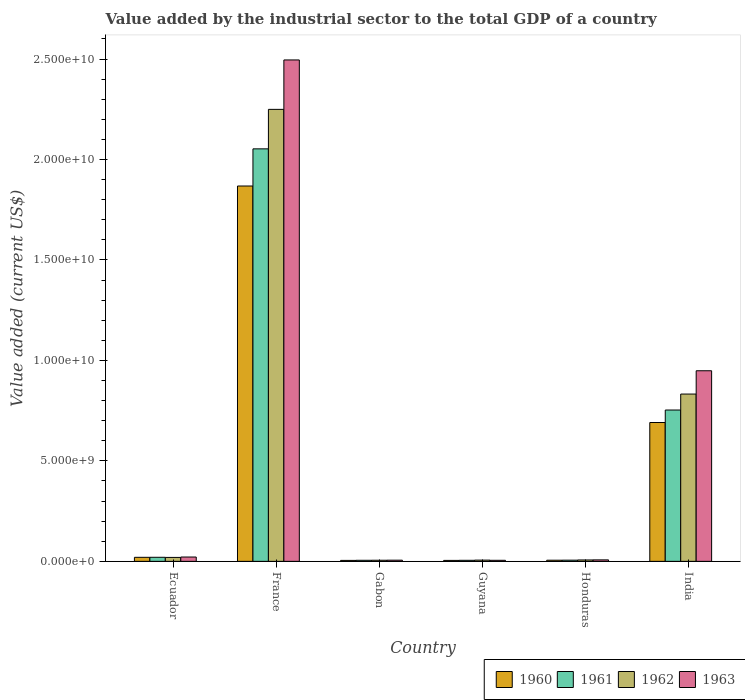Are the number of bars on each tick of the X-axis equal?
Offer a very short reply. Yes. What is the label of the 5th group of bars from the left?
Make the answer very short. Honduras. In how many cases, is the number of bars for a given country not equal to the number of legend labels?
Keep it short and to the point. 0. What is the value added by the industrial sector to the total GDP in 1962 in Gabon?
Offer a very short reply. 5.59e+07. Across all countries, what is the maximum value added by the industrial sector to the total GDP in 1962?
Offer a terse response. 2.25e+1. Across all countries, what is the minimum value added by the industrial sector to the total GDP in 1960?
Make the answer very short. 4.74e+07. In which country was the value added by the industrial sector to the total GDP in 1962 minimum?
Your answer should be very brief. Gabon. What is the total value added by the industrial sector to the total GDP in 1962 in the graph?
Your answer should be very brief. 3.12e+1. What is the difference between the value added by the industrial sector to the total GDP in 1963 in Ecuador and that in India?
Offer a terse response. -9.27e+09. What is the difference between the value added by the industrial sector to the total GDP in 1961 in Guyana and the value added by the industrial sector to the total GDP in 1962 in Ecuador?
Provide a succinct answer. -1.44e+08. What is the average value added by the industrial sector to the total GDP in 1961 per country?
Your response must be concise. 4.74e+09. What is the difference between the value added by the industrial sector to the total GDP of/in 1960 and value added by the industrial sector to the total GDP of/in 1963 in Ecuador?
Offer a very short reply. -1.55e+07. What is the ratio of the value added by the industrial sector to the total GDP in 1962 in France to that in Gabon?
Provide a short and direct response. 402.11. What is the difference between the highest and the second highest value added by the industrial sector to the total GDP in 1962?
Keep it short and to the point. 8.13e+09. What is the difference between the highest and the lowest value added by the industrial sector to the total GDP in 1961?
Provide a short and direct response. 2.05e+1. In how many countries, is the value added by the industrial sector to the total GDP in 1961 greater than the average value added by the industrial sector to the total GDP in 1961 taken over all countries?
Your response must be concise. 2. What does the 2nd bar from the right in Guyana represents?
Ensure brevity in your answer.  1962. Is it the case that in every country, the sum of the value added by the industrial sector to the total GDP in 1960 and value added by the industrial sector to the total GDP in 1962 is greater than the value added by the industrial sector to the total GDP in 1963?
Your response must be concise. Yes. Are all the bars in the graph horizontal?
Your response must be concise. No. What is the difference between two consecutive major ticks on the Y-axis?
Keep it short and to the point. 5.00e+09. Are the values on the major ticks of Y-axis written in scientific E-notation?
Provide a short and direct response. Yes. How many legend labels are there?
Provide a short and direct response. 4. What is the title of the graph?
Keep it short and to the point. Value added by the industrial sector to the total GDP of a country. Does "1992" appear as one of the legend labels in the graph?
Your answer should be compact. No. What is the label or title of the Y-axis?
Give a very brief answer. Value added (current US$). What is the Value added (current US$) of 1960 in Ecuador?
Your response must be concise. 2.01e+08. What is the Value added (current US$) in 1961 in Ecuador?
Your response must be concise. 2.02e+08. What is the Value added (current US$) in 1962 in Ecuador?
Provide a short and direct response. 1.96e+08. What is the Value added (current US$) of 1963 in Ecuador?
Ensure brevity in your answer.  2.16e+08. What is the Value added (current US$) of 1960 in France?
Your response must be concise. 1.87e+1. What is the Value added (current US$) of 1961 in France?
Keep it short and to the point. 2.05e+1. What is the Value added (current US$) of 1962 in France?
Make the answer very short. 2.25e+1. What is the Value added (current US$) of 1963 in France?
Offer a very short reply. 2.50e+1. What is the Value added (current US$) in 1960 in Gabon?
Provide a succinct answer. 4.80e+07. What is the Value added (current US$) in 1961 in Gabon?
Provide a succinct answer. 5.29e+07. What is the Value added (current US$) of 1962 in Gabon?
Offer a terse response. 5.59e+07. What is the Value added (current US$) in 1963 in Gabon?
Make the answer very short. 5.89e+07. What is the Value added (current US$) in 1960 in Guyana?
Provide a short and direct response. 4.74e+07. What is the Value added (current US$) in 1961 in Guyana?
Your answer should be very brief. 5.23e+07. What is the Value added (current US$) of 1962 in Guyana?
Offer a very short reply. 6.20e+07. What is the Value added (current US$) of 1963 in Guyana?
Your answer should be compact. 5.21e+07. What is the Value added (current US$) in 1960 in Honduras?
Your answer should be very brief. 5.73e+07. What is the Value added (current US$) in 1961 in Honduras?
Give a very brief answer. 5.94e+07. What is the Value added (current US$) of 1962 in Honduras?
Make the answer very short. 6.92e+07. What is the Value added (current US$) in 1963 in Honduras?
Ensure brevity in your answer.  7.38e+07. What is the Value added (current US$) of 1960 in India?
Provide a succinct answer. 6.91e+09. What is the Value added (current US$) in 1961 in India?
Make the answer very short. 7.53e+09. What is the Value added (current US$) of 1962 in India?
Keep it short and to the point. 8.33e+09. What is the Value added (current US$) in 1963 in India?
Keep it short and to the point. 9.49e+09. Across all countries, what is the maximum Value added (current US$) of 1960?
Your response must be concise. 1.87e+1. Across all countries, what is the maximum Value added (current US$) of 1961?
Give a very brief answer. 2.05e+1. Across all countries, what is the maximum Value added (current US$) of 1962?
Offer a very short reply. 2.25e+1. Across all countries, what is the maximum Value added (current US$) of 1963?
Make the answer very short. 2.50e+1. Across all countries, what is the minimum Value added (current US$) in 1960?
Your answer should be compact. 4.74e+07. Across all countries, what is the minimum Value added (current US$) of 1961?
Make the answer very short. 5.23e+07. Across all countries, what is the minimum Value added (current US$) in 1962?
Provide a succinct answer. 5.59e+07. Across all countries, what is the minimum Value added (current US$) of 1963?
Provide a short and direct response. 5.21e+07. What is the total Value added (current US$) in 1960 in the graph?
Provide a succinct answer. 2.59e+1. What is the total Value added (current US$) of 1961 in the graph?
Keep it short and to the point. 2.84e+1. What is the total Value added (current US$) of 1962 in the graph?
Your answer should be very brief. 3.12e+1. What is the total Value added (current US$) of 1963 in the graph?
Keep it short and to the point. 3.48e+1. What is the difference between the Value added (current US$) of 1960 in Ecuador and that in France?
Keep it short and to the point. -1.85e+1. What is the difference between the Value added (current US$) of 1961 in Ecuador and that in France?
Provide a short and direct response. -2.03e+1. What is the difference between the Value added (current US$) in 1962 in Ecuador and that in France?
Provide a short and direct response. -2.23e+1. What is the difference between the Value added (current US$) of 1963 in Ecuador and that in France?
Provide a short and direct response. -2.47e+1. What is the difference between the Value added (current US$) of 1960 in Ecuador and that in Gabon?
Provide a short and direct response. 1.53e+08. What is the difference between the Value added (current US$) of 1961 in Ecuador and that in Gabon?
Provide a short and direct response. 1.49e+08. What is the difference between the Value added (current US$) in 1962 in Ecuador and that in Gabon?
Provide a short and direct response. 1.40e+08. What is the difference between the Value added (current US$) in 1963 in Ecuador and that in Gabon?
Your response must be concise. 1.57e+08. What is the difference between the Value added (current US$) of 1960 in Ecuador and that in Guyana?
Keep it short and to the point. 1.53e+08. What is the difference between the Value added (current US$) of 1961 in Ecuador and that in Guyana?
Your answer should be compact. 1.50e+08. What is the difference between the Value added (current US$) of 1962 in Ecuador and that in Guyana?
Give a very brief answer. 1.34e+08. What is the difference between the Value added (current US$) in 1963 in Ecuador and that in Guyana?
Offer a terse response. 1.64e+08. What is the difference between the Value added (current US$) of 1960 in Ecuador and that in Honduras?
Provide a succinct answer. 1.43e+08. What is the difference between the Value added (current US$) in 1961 in Ecuador and that in Honduras?
Make the answer very short. 1.43e+08. What is the difference between the Value added (current US$) in 1962 in Ecuador and that in Honduras?
Your answer should be very brief. 1.27e+08. What is the difference between the Value added (current US$) in 1963 in Ecuador and that in Honduras?
Your answer should be very brief. 1.42e+08. What is the difference between the Value added (current US$) of 1960 in Ecuador and that in India?
Keep it short and to the point. -6.71e+09. What is the difference between the Value added (current US$) of 1961 in Ecuador and that in India?
Your answer should be compact. -7.33e+09. What is the difference between the Value added (current US$) of 1962 in Ecuador and that in India?
Your answer should be very brief. -8.13e+09. What is the difference between the Value added (current US$) in 1963 in Ecuador and that in India?
Make the answer very short. -9.27e+09. What is the difference between the Value added (current US$) of 1960 in France and that in Gabon?
Keep it short and to the point. 1.86e+1. What is the difference between the Value added (current US$) in 1961 in France and that in Gabon?
Keep it short and to the point. 2.05e+1. What is the difference between the Value added (current US$) in 1962 in France and that in Gabon?
Offer a terse response. 2.24e+1. What is the difference between the Value added (current US$) of 1963 in France and that in Gabon?
Your answer should be very brief. 2.49e+1. What is the difference between the Value added (current US$) of 1960 in France and that in Guyana?
Keep it short and to the point. 1.86e+1. What is the difference between the Value added (current US$) in 1961 in France and that in Guyana?
Make the answer very short. 2.05e+1. What is the difference between the Value added (current US$) in 1962 in France and that in Guyana?
Make the answer very short. 2.24e+1. What is the difference between the Value added (current US$) in 1963 in France and that in Guyana?
Your answer should be very brief. 2.49e+1. What is the difference between the Value added (current US$) of 1960 in France and that in Honduras?
Provide a short and direct response. 1.86e+1. What is the difference between the Value added (current US$) in 1961 in France and that in Honduras?
Make the answer very short. 2.05e+1. What is the difference between the Value added (current US$) of 1962 in France and that in Honduras?
Your response must be concise. 2.24e+1. What is the difference between the Value added (current US$) of 1963 in France and that in Honduras?
Provide a short and direct response. 2.49e+1. What is the difference between the Value added (current US$) in 1960 in France and that in India?
Keep it short and to the point. 1.18e+1. What is the difference between the Value added (current US$) in 1961 in France and that in India?
Your answer should be very brief. 1.30e+1. What is the difference between the Value added (current US$) in 1962 in France and that in India?
Your answer should be very brief. 1.42e+1. What is the difference between the Value added (current US$) in 1963 in France and that in India?
Offer a very short reply. 1.55e+1. What is the difference between the Value added (current US$) of 1960 in Gabon and that in Guyana?
Your response must be concise. 5.58e+05. What is the difference between the Value added (current US$) in 1961 in Gabon and that in Guyana?
Ensure brevity in your answer.  6.49e+05. What is the difference between the Value added (current US$) of 1962 in Gabon and that in Guyana?
Provide a succinct answer. -6.07e+06. What is the difference between the Value added (current US$) in 1963 in Gabon and that in Guyana?
Provide a succinct answer. 6.82e+06. What is the difference between the Value added (current US$) in 1960 in Gabon and that in Honduras?
Make the answer very short. -9.32e+06. What is the difference between the Value added (current US$) in 1961 in Gabon and that in Honduras?
Ensure brevity in your answer.  -6.43e+06. What is the difference between the Value added (current US$) in 1962 in Gabon and that in Honduras?
Make the answer very short. -1.33e+07. What is the difference between the Value added (current US$) of 1963 in Gabon and that in Honduras?
Give a very brief answer. -1.49e+07. What is the difference between the Value added (current US$) in 1960 in Gabon and that in India?
Provide a short and direct response. -6.86e+09. What is the difference between the Value added (current US$) in 1961 in Gabon and that in India?
Ensure brevity in your answer.  -7.48e+09. What is the difference between the Value added (current US$) in 1962 in Gabon and that in India?
Provide a succinct answer. -8.27e+09. What is the difference between the Value added (current US$) of 1963 in Gabon and that in India?
Offer a terse response. -9.43e+09. What is the difference between the Value added (current US$) of 1960 in Guyana and that in Honduras?
Provide a short and direct response. -9.88e+06. What is the difference between the Value added (current US$) in 1961 in Guyana and that in Honduras?
Provide a succinct answer. -7.08e+06. What is the difference between the Value added (current US$) in 1962 in Guyana and that in Honduras?
Keep it short and to the point. -7.19e+06. What is the difference between the Value added (current US$) in 1963 in Guyana and that in Honduras?
Offer a terse response. -2.17e+07. What is the difference between the Value added (current US$) in 1960 in Guyana and that in India?
Provide a succinct answer. -6.86e+09. What is the difference between the Value added (current US$) of 1961 in Guyana and that in India?
Make the answer very short. -7.48e+09. What is the difference between the Value added (current US$) of 1962 in Guyana and that in India?
Offer a terse response. -8.26e+09. What is the difference between the Value added (current US$) of 1963 in Guyana and that in India?
Your answer should be compact. -9.43e+09. What is the difference between the Value added (current US$) of 1960 in Honduras and that in India?
Your response must be concise. -6.85e+09. What is the difference between the Value added (current US$) of 1961 in Honduras and that in India?
Your response must be concise. -7.47e+09. What is the difference between the Value added (current US$) of 1962 in Honduras and that in India?
Your answer should be compact. -8.26e+09. What is the difference between the Value added (current US$) of 1963 in Honduras and that in India?
Ensure brevity in your answer.  -9.41e+09. What is the difference between the Value added (current US$) in 1960 in Ecuador and the Value added (current US$) in 1961 in France?
Offer a very short reply. -2.03e+1. What is the difference between the Value added (current US$) of 1960 in Ecuador and the Value added (current US$) of 1962 in France?
Your answer should be very brief. -2.23e+1. What is the difference between the Value added (current US$) in 1960 in Ecuador and the Value added (current US$) in 1963 in France?
Give a very brief answer. -2.48e+1. What is the difference between the Value added (current US$) of 1961 in Ecuador and the Value added (current US$) of 1962 in France?
Your response must be concise. -2.23e+1. What is the difference between the Value added (current US$) in 1961 in Ecuador and the Value added (current US$) in 1963 in France?
Provide a succinct answer. -2.48e+1. What is the difference between the Value added (current US$) of 1962 in Ecuador and the Value added (current US$) of 1963 in France?
Make the answer very short. -2.48e+1. What is the difference between the Value added (current US$) in 1960 in Ecuador and the Value added (current US$) in 1961 in Gabon?
Offer a terse response. 1.48e+08. What is the difference between the Value added (current US$) in 1960 in Ecuador and the Value added (current US$) in 1962 in Gabon?
Offer a very short reply. 1.45e+08. What is the difference between the Value added (current US$) of 1960 in Ecuador and the Value added (current US$) of 1963 in Gabon?
Give a very brief answer. 1.42e+08. What is the difference between the Value added (current US$) of 1961 in Ecuador and the Value added (current US$) of 1962 in Gabon?
Provide a short and direct response. 1.46e+08. What is the difference between the Value added (current US$) of 1961 in Ecuador and the Value added (current US$) of 1963 in Gabon?
Make the answer very short. 1.43e+08. What is the difference between the Value added (current US$) in 1962 in Ecuador and the Value added (current US$) in 1963 in Gabon?
Your response must be concise. 1.37e+08. What is the difference between the Value added (current US$) of 1960 in Ecuador and the Value added (current US$) of 1961 in Guyana?
Your answer should be very brief. 1.48e+08. What is the difference between the Value added (current US$) of 1960 in Ecuador and the Value added (current US$) of 1962 in Guyana?
Your answer should be very brief. 1.39e+08. What is the difference between the Value added (current US$) of 1960 in Ecuador and the Value added (current US$) of 1963 in Guyana?
Offer a very short reply. 1.49e+08. What is the difference between the Value added (current US$) of 1961 in Ecuador and the Value added (current US$) of 1962 in Guyana?
Keep it short and to the point. 1.40e+08. What is the difference between the Value added (current US$) in 1961 in Ecuador and the Value added (current US$) in 1963 in Guyana?
Provide a short and direct response. 1.50e+08. What is the difference between the Value added (current US$) in 1962 in Ecuador and the Value added (current US$) in 1963 in Guyana?
Give a very brief answer. 1.44e+08. What is the difference between the Value added (current US$) in 1960 in Ecuador and the Value added (current US$) in 1961 in Honduras?
Give a very brief answer. 1.41e+08. What is the difference between the Value added (current US$) in 1960 in Ecuador and the Value added (current US$) in 1962 in Honduras?
Give a very brief answer. 1.31e+08. What is the difference between the Value added (current US$) of 1960 in Ecuador and the Value added (current US$) of 1963 in Honduras?
Your response must be concise. 1.27e+08. What is the difference between the Value added (current US$) of 1961 in Ecuador and the Value added (current US$) of 1962 in Honduras?
Offer a very short reply. 1.33e+08. What is the difference between the Value added (current US$) of 1961 in Ecuador and the Value added (current US$) of 1963 in Honduras?
Make the answer very short. 1.28e+08. What is the difference between the Value added (current US$) in 1962 in Ecuador and the Value added (current US$) in 1963 in Honduras?
Offer a very short reply. 1.22e+08. What is the difference between the Value added (current US$) in 1960 in Ecuador and the Value added (current US$) in 1961 in India?
Your response must be concise. -7.33e+09. What is the difference between the Value added (current US$) in 1960 in Ecuador and the Value added (current US$) in 1962 in India?
Offer a terse response. -8.13e+09. What is the difference between the Value added (current US$) in 1960 in Ecuador and the Value added (current US$) in 1963 in India?
Provide a short and direct response. -9.28e+09. What is the difference between the Value added (current US$) in 1961 in Ecuador and the Value added (current US$) in 1962 in India?
Give a very brief answer. -8.12e+09. What is the difference between the Value added (current US$) of 1961 in Ecuador and the Value added (current US$) of 1963 in India?
Your response must be concise. -9.28e+09. What is the difference between the Value added (current US$) in 1962 in Ecuador and the Value added (current US$) in 1963 in India?
Give a very brief answer. -9.29e+09. What is the difference between the Value added (current US$) in 1960 in France and the Value added (current US$) in 1961 in Gabon?
Make the answer very short. 1.86e+1. What is the difference between the Value added (current US$) of 1960 in France and the Value added (current US$) of 1962 in Gabon?
Offer a terse response. 1.86e+1. What is the difference between the Value added (current US$) in 1960 in France and the Value added (current US$) in 1963 in Gabon?
Ensure brevity in your answer.  1.86e+1. What is the difference between the Value added (current US$) of 1961 in France and the Value added (current US$) of 1962 in Gabon?
Provide a succinct answer. 2.05e+1. What is the difference between the Value added (current US$) of 1961 in France and the Value added (current US$) of 1963 in Gabon?
Your answer should be very brief. 2.05e+1. What is the difference between the Value added (current US$) of 1962 in France and the Value added (current US$) of 1963 in Gabon?
Provide a short and direct response. 2.24e+1. What is the difference between the Value added (current US$) of 1960 in France and the Value added (current US$) of 1961 in Guyana?
Keep it short and to the point. 1.86e+1. What is the difference between the Value added (current US$) in 1960 in France and the Value added (current US$) in 1962 in Guyana?
Keep it short and to the point. 1.86e+1. What is the difference between the Value added (current US$) of 1960 in France and the Value added (current US$) of 1963 in Guyana?
Your response must be concise. 1.86e+1. What is the difference between the Value added (current US$) of 1961 in France and the Value added (current US$) of 1962 in Guyana?
Offer a terse response. 2.05e+1. What is the difference between the Value added (current US$) of 1961 in France and the Value added (current US$) of 1963 in Guyana?
Make the answer very short. 2.05e+1. What is the difference between the Value added (current US$) of 1962 in France and the Value added (current US$) of 1963 in Guyana?
Provide a short and direct response. 2.24e+1. What is the difference between the Value added (current US$) in 1960 in France and the Value added (current US$) in 1961 in Honduras?
Provide a short and direct response. 1.86e+1. What is the difference between the Value added (current US$) in 1960 in France and the Value added (current US$) in 1962 in Honduras?
Provide a succinct answer. 1.86e+1. What is the difference between the Value added (current US$) in 1960 in France and the Value added (current US$) in 1963 in Honduras?
Offer a terse response. 1.86e+1. What is the difference between the Value added (current US$) in 1961 in France and the Value added (current US$) in 1962 in Honduras?
Provide a succinct answer. 2.05e+1. What is the difference between the Value added (current US$) of 1961 in France and the Value added (current US$) of 1963 in Honduras?
Keep it short and to the point. 2.05e+1. What is the difference between the Value added (current US$) in 1962 in France and the Value added (current US$) in 1963 in Honduras?
Ensure brevity in your answer.  2.24e+1. What is the difference between the Value added (current US$) in 1960 in France and the Value added (current US$) in 1961 in India?
Offer a very short reply. 1.11e+1. What is the difference between the Value added (current US$) of 1960 in France and the Value added (current US$) of 1962 in India?
Give a very brief answer. 1.04e+1. What is the difference between the Value added (current US$) of 1960 in France and the Value added (current US$) of 1963 in India?
Offer a terse response. 9.19e+09. What is the difference between the Value added (current US$) of 1961 in France and the Value added (current US$) of 1962 in India?
Provide a succinct answer. 1.22e+1. What is the difference between the Value added (current US$) of 1961 in France and the Value added (current US$) of 1963 in India?
Offer a very short reply. 1.10e+1. What is the difference between the Value added (current US$) of 1962 in France and the Value added (current US$) of 1963 in India?
Your answer should be compact. 1.30e+1. What is the difference between the Value added (current US$) of 1960 in Gabon and the Value added (current US$) of 1961 in Guyana?
Make the answer very short. -4.28e+06. What is the difference between the Value added (current US$) of 1960 in Gabon and the Value added (current US$) of 1962 in Guyana?
Provide a short and direct response. -1.40e+07. What is the difference between the Value added (current US$) in 1960 in Gabon and the Value added (current US$) in 1963 in Guyana?
Offer a terse response. -4.11e+06. What is the difference between the Value added (current US$) of 1961 in Gabon and the Value added (current US$) of 1962 in Guyana?
Make the answer very short. -9.09e+06. What is the difference between the Value added (current US$) of 1961 in Gabon and the Value added (current US$) of 1963 in Guyana?
Provide a short and direct response. 8.24e+05. What is the difference between the Value added (current US$) of 1962 in Gabon and the Value added (current US$) of 1963 in Guyana?
Provide a short and direct response. 3.85e+06. What is the difference between the Value added (current US$) of 1960 in Gabon and the Value added (current US$) of 1961 in Honduras?
Give a very brief answer. -1.14e+07. What is the difference between the Value added (current US$) of 1960 in Gabon and the Value added (current US$) of 1962 in Honduras?
Provide a succinct answer. -2.12e+07. What is the difference between the Value added (current US$) of 1960 in Gabon and the Value added (current US$) of 1963 in Honduras?
Your answer should be very brief. -2.58e+07. What is the difference between the Value added (current US$) of 1961 in Gabon and the Value added (current US$) of 1962 in Honduras?
Offer a very short reply. -1.63e+07. What is the difference between the Value added (current US$) of 1961 in Gabon and the Value added (current US$) of 1963 in Honduras?
Provide a succinct answer. -2.09e+07. What is the difference between the Value added (current US$) of 1962 in Gabon and the Value added (current US$) of 1963 in Honduras?
Give a very brief answer. -1.79e+07. What is the difference between the Value added (current US$) of 1960 in Gabon and the Value added (current US$) of 1961 in India?
Offer a very short reply. -7.48e+09. What is the difference between the Value added (current US$) of 1960 in Gabon and the Value added (current US$) of 1962 in India?
Provide a succinct answer. -8.28e+09. What is the difference between the Value added (current US$) of 1960 in Gabon and the Value added (current US$) of 1963 in India?
Provide a succinct answer. -9.44e+09. What is the difference between the Value added (current US$) of 1961 in Gabon and the Value added (current US$) of 1962 in India?
Provide a succinct answer. -8.27e+09. What is the difference between the Value added (current US$) in 1961 in Gabon and the Value added (current US$) in 1963 in India?
Your answer should be very brief. -9.43e+09. What is the difference between the Value added (current US$) of 1962 in Gabon and the Value added (current US$) of 1963 in India?
Make the answer very short. -9.43e+09. What is the difference between the Value added (current US$) in 1960 in Guyana and the Value added (current US$) in 1961 in Honduras?
Keep it short and to the point. -1.19e+07. What is the difference between the Value added (current US$) of 1960 in Guyana and the Value added (current US$) of 1962 in Honduras?
Give a very brief answer. -2.18e+07. What is the difference between the Value added (current US$) of 1960 in Guyana and the Value added (current US$) of 1963 in Honduras?
Your response must be concise. -2.64e+07. What is the difference between the Value added (current US$) of 1961 in Guyana and the Value added (current US$) of 1962 in Honduras?
Your answer should be compact. -1.69e+07. What is the difference between the Value added (current US$) of 1961 in Guyana and the Value added (current US$) of 1963 in Honduras?
Give a very brief answer. -2.15e+07. What is the difference between the Value added (current US$) in 1962 in Guyana and the Value added (current US$) in 1963 in Honduras?
Make the answer very short. -1.18e+07. What is the difference between the Value added (current US$) of 1960 in Guyana and the Value added (current US$) of 1961 in India?
Keep it short and to the point. -7.48e+09. What is the difference between the Value added (current US$) of 1960 in Guyana and the Value added (current US$) of 1962 in India?
Offer a very short reply. -8.28e+09. What is the difference between the Value added (current US$) in 1960 in Guyana and the Value added (current US$) in 1963 in India?
Ensure brevity in your answer.  -9.44e+09. What is the difference between the Value added (current US$) in 1961 in Guyana and the Value added (current US$) in 1962 in India?
Give a very brief answer. -8.27e+09. What is the difference between the Value added (current US$) of 1961 in Guyana and the Value added (current US$) of 1963 in India?
Your answer should be very brief. -9.43e+09. What is the difference between the Value added (current US$) of 1962 in Guyana and the Value added (current US$) of 1963 in India?
Provide a succinct answer. -9.42e+09. What is the difference between the Value added (current US$) of 1960 in Honduras and the Value added (current US$) of 1961 in India?
Make the answer very short. -7.47e+09. What is the difference between the Value added (current US$) in 1960 in Honduras and the Value added (current US$) in 1962 in India?
Offer a terse response. -8.27e+09. What is the difference between the Value added (current US$) of 1960 in Honduras and the Value added (current US$) of 1963 in India?
Give a very brief answer. -9.43e+09. What is the difference between the Value added (current US$) in 1961 in Honduras and the Value added (current US$) in 1962 in India?
Offer a very short reply. -8.27e+09. What is the difference between the Value added (current US$) of 1961 in Honduras and the Value added (current US$) of 1963 in India?
Keep it short and to the point. -9.43e+09. What is the difference between the Value added (current US$) in 1962 in Honduras and the Value added (current US$) in 1963 in India?
Provide a short and direct response. -9.42e+09. What is the average Value added (current US$) of 1960 per country?
Offer a terse response. 4.32e+09. What is the average Value added (current US$) in 1961 per country?
Your response must be concise. 4.74e+09. What is the average Value added (current US$) in 1962 per country?
Keep it short and to the point. 5.20e+09. What is the average Value added (current US$) of 1963 per country?
Make the answer very short. 5.81e+09. What is the difference between the Value added (current US$) in 1960 and Value added (current US$) in 1961 in Ecuador?
Your answer should be very brief. -1.51e+06. What is the difference between the Value added (current US$) of 1960 and Value added (current US$) of 1962 in Ecuador?
Offer a terse response. 4.47e+06. What is the difference between the Value added (current US$) of 1960 and Value added (current US$) of 1963 in Ecuador?
Give a very brief answer. -1.55e+07. What is the difference between the Value added (current US$) of 1961 and Value added (current US$) of 1962 in Ecuador?
Your response must be concise. 5.98e+06. What is the difference between the Value added (current US$) of 1961 and Value added (current US$) of 1963 in Ecuador?
Give a very brief answer. -1.39e+07. What is the difference between the Value added (current US$) in 1962 and Value added (current US$) in 1963 in Ecuador?
Offer a very short reply. -1.99e+07. What is the difference between the Value added (current US$) of 1960 and Value added (current US$) of 1961 in France?
Your answer should be very brief. -1.85e+09. What is the difference between the Value added (current US$) in 1960 and Value added (current US$) in 1962 in France?
Provide a short and direct response. -3.81e+09. What is the difference between the Value added (current US$) in 1960 and Value added (current US$) in 1963 in France?
Offer a very short reply. -6.27e+09. What is the difference between the Value added (current US$) in 1961 and Value added (current US$) in 1962 in France?
Offer a very short reply. -1.97e+09. What is the difference between the Value added (current US$) in 1961 and Value added (current US$) in 1963 in France?
Your response must be concise. -4.42e+09. What is the difference between the Value added (current US$) in 1962 and Value added (current US$) in 1963 in France?
Keep it short and to the point. -2.46e+09. What is the difference between the Value added (current US$) in 1960 and Value added (current US$) in 1961 in Gabon?
Make the answer very short. -4.93e+06. What is the difference between the Value added (current US$) of 1960 and Value added (current US$) of 1962 in Gabon?
Keep it short and to the point. -7.96e+06. What is the difference between the Value added (current US$) of 1960 and Value added (current US$) of 1963 in Gabon?
Provide a short and direct response. -1.09e+07. What is the difference between the Value added (current US$) of 1961 and Value added (current US$) of 1962 in Gabon?
Make the answer very short. -3.02e+06. What is the difference between the Value added (current US$) in 1961 and Value added (current US$) in 1963 in Gabon?
Provide a succinct answer. -5.99e+06. What is the difference between the Value added (current US$) of 1962 and Value added (current US$) of 1963 in Gabon?
Give a very brief answer. -2.97e+06. What is the difference between the Value added (current US$) of 1960 and Value added (current US$) of 1961 in Guyana?
Ensure brevity in your answer.  -4.84e+06. What is the difference between the Value added (current US$) in 1960 and Value added (current US$) in 1962 in Guyana?
Your response must be concise. -1.46e+07. What is the difference between the Value added (current US$) of 1960 and Value added (current US$) of 1963 in Guyana?
Offer a terse response. -4.67e+06. What is the difference between the Value added (current US$) in 1961 and Value added (current US$) in 1962 in Guyana?
Offer a very short reply. -9.74e+06. What is the difference between the Value added (current US$) of 1961 and Value added (current US$) of 1963 in Guyana?
Keep it short and to the point. 1.75e+05. What is the difference between the Value added (current US$) of 1962 and Value added (current US$) of 1963 in Guyana?
Provide a succinct answer. 9.92e+06. What is the difference between the Value added (current US$) of 1960 and Value added (current US$) of 1961 in Honduras?
Make the answer very short. -2.05e+06. What is the difference between the Value added (current US$) in 1960 and Value added (current US$) in 1962 in Honduras?
Your response must be concise. -1.19e+07. What is the difference between the Value added (current US$) in 1960 and Value added (current US$) in 1963 in Honduras?
Keep it short and to the point. -1.65e+07. What is the difference between the Value added (current US$) in 1961 and Value added (current US$) in 1962 in Honduras?
Your answer should be very brief. -9.85e+06. What is the difference between the Value added (current US$) in 1961 and Value added (current US$) in 1963 in Honduras?
Your response must be concise. -1.44e+07. What is the difference between the Value added (current US$) in 1962 and Value added (current US$) in 1963 in Honduras?
Provide a short and direct response. -4.60e+06. What is the difference between the Value added (current US$) in 1960 and Value added (current US$) in 1961 in India?
Provide a short and direct response. -6.21e+08. What is the difference between the Value added (current US$) in 1960 and Value added (current US$) in 1962 in India?
Give a very brief answer. -1.42e+09. What is the difference between the Value added (current US$) of 1960 and Value added (current US$) of 1963 in India?
Offer a very short reply. -2.58e+09. What is the difference between the Value added (current US$) in 1961 and Value added (current US$) in 1962 in India?
Offer a terse response. -7.94e+08. What is the difference between the Value added (current US$) of 1961 and Value added (current US$) of 1963 in India?
Your response must be concise. -1.95e+09. What is the difference between the Value added (current US$) in 1962 and Value added (current US$) in 1963 in India?
Ensure brevity in your answer.  -1.16e+09. What is the ratio of the Value added (current US$) in 1960 in Ecuador to that in France?
Your answer should be compact. 0.01. What is the ratio of the Value added (current US$) in 1961 in Ecuador to that in France?
Keep it short and to the point. 0.01. What is the ratio of the Value added (current US$) of 1962 in Ecuador to that in France?
Ensure brevity in your answer.  0.01. What is the ratio of the Value added (current US$) in 1963 in Ecuador to that in France?
Give a very brief answer. 0.01. What is the ratio of the Value added (current US$) of 1960 in Ecuador to that in Gabon?
Ensure brevity in your answer.  4.18. What is the ratio of the Value added (current US$) of 1961 in Ecuador to that in Gabon?
Ensure brevity in your answer.  3.82. What is the ratio of the Value added (current US$) in 1962 in Ecuador to that in Gabon?
Keep it short and to the point. 3.51. What is the ratio of the Value added (current US$) in 1963 in Ecuador to that in Gabon?
Offer a terse response. 3.67. What is the ratio of the Value added (current US$) in 1960 in Ecuador to that in Guyana?
Keep it short and to the point. 4.23. What is the ratio of the Value added (current US$) of 1961 in Ecuador to that in Guyana?
Your answer should be very brief. 3.87. What is the ratio of the Value added (current US$) of 1962 in Ecuador to that in Guyana?
Make the answer very short. 3.16. What is the ratio of the Value added (current US$) of 1963 in Ecuador to that in Guyana?
Offer a terse response. 4.15. What is the ratio of the Value added (current US$) of 1960 in Ecuador to that in Honduras?
Give a very brief answer. 3.5. What is the ratio of the Value added (current US$) in 1961 in Ecuador to that in Honduras?
Offer a terse response. 3.41. What is the ratio of the Value added (current US$) of 1962 in Ecuador to that in Honduras?
Give a very brief answer. 2.83. What is the ratio of the Value added (current US$) in 1963 in Ecuador to that in Honduras?
Your answer should be very brief. 2.93. What is the ratio of the Value added (current US$) of 1960 in Ecuador to that in India?
Make the answer very short. 0.03. What is the ratio of the Value added (current US$) in 1961 in Ecuador to that in India?
Your response must be concise. 0.03. What is the ratio of the Value added (current US$) in 1962 in Ecuador to that in India?
Provide a succinct answer. 0.02. What is the ratio of the Value added (current US$) of 1963 in Ecuador to that in India?
Ensure brevity in your answer.  0.02. What is the ratio of the Value added (current US$) of 1960 in France to that in Gabon?
Keep it short and to the point. 389.29. What is the ratio of the Value added (current US$) of 1961 in France to that in Gabon?
Give a very brief answer. 387.95. What is the ratio of the Value added (current US$) of 1962 in France to that in Gabon?
Provide a succinct answer. 402.11. What is the ratio of the Value added (current US$) of 1963 in France to that in Gabon?
Your answer should be compact. 423.59. What is the ratio of the Value added (current US$) in 1960 in France to that in Guyana?
Offer a terse response. 393.87. What is the ratio of the Value added (current US$) of 1961 in France to that in Guyana?
Provide a short and direct response. 392.77. What is the ratio of the Value added (current US$) of 1962 in France to that in Guyana?
Your answer should be compact. 362.76. What is the ratio of the Value added (current US$) of 1963 in France to that in Guyana?
Give a very brief answer. 479.03. What is the ratio of the Value added (current US$) in 1960 in France to that in Honduras?
Your answer should be compact. 325.99. What is the ratio of the Value added (current US$) of 1961 in France to that in Honduras?
Make the answer very short. 345.89. What is the ratio of the Value added (current US$) of 1962 in France to that in Honduras?
Offer a very short reply. 325.06. What is the ratio of the Value added (current US$) in 1963 in France to that in Honduras?
Keep it short and to the point. 338.12. What is the ratio of the Value added (current US$) in 1960 in France to that in India?
Offer a terse response. 2.7. What is the ratio of the Value added (current US$) of 1961 in France to that in India?
Ensure brevity in your answer.  2.73. What is the ratio of the Value added (current US$) in 1962 in France to that in India?
Your answer should be very brief. 2.7. What is the ratio of the Value added (current US$) of 1963 in France to that in India?
Your answer should be very brief. 2.63. What is the ratio of the Value added (current US$) of 1960 in Gabon to that in Guyana?
Offer a terse response. 1.01. What is the ratio of the Value added (current US$) of 1961 in Gabon to that in Guyana?
Make the answer very short. 1.01. What is the ratio of the Value added (current US$) of 1962 in Gabon to that in Guyana?
Make the answer very short. 0.9. What is the ratio of the Value added (current US$) of 1963 in Gabon to that in Guyana?
Your answer should be compact. 1.13. What is the ratio of the Value added (current US$) in 1960 in Gabon to that in Honduras?
Your answer should be compact. 0.84. What is the ratio of the Value added (current US$) of 1961 in Gabon to that in Honduras?
Provide a short and direct response. 0.89. What is the ratio of the Value added (current US$) in 1962 in Gabon to that in Honduras?
Ensure brevity in your answer.  0.81. What is the ratio of the Value added (current US$) of 1963 in Gabon to that in Honduras?
Your answer should be compact. 0.8. What is the ratio of the Value added (current US$) in 1960 in Gabon to that in India?
Ensure brevity in your answer.  0.01. What is the ratio of the Value added (current US$) of 1961 in Gabon to that in India?
Provide a short and direct response. 0.01. What is the ratio of the Value added (current US$) in 1962 in Gabon to that in India?
Ensure brevity in your answer.  0.01. What is the ratio of the Value added (current US$) in 1963 in Gabon to that in India?
Keep it short and to the point. 0.01. What is the ratio of the Value added (current US$) of 1960 in Guyana to that in Honduras?
Your response must be concise. 0.83. What is the ratio of the Value added (current US$) in 1961 in Guyana to that in Honduras?
Provide a short and direct response. 0.88. What is the ratio of the Value added (current US$) of 1962 in Guyana to that in Honduras?
Your answer should be compact. 0.9. What is the ratio of the Value added (current US$) of 1963 in Guyana to that in Honduras?
Ensure brevity in your answer.  0.71. What is the ratio of the Value added (current US$) in 1960 in Guyana to that in India?
Keep it short and to the point. 0.01. What is the ratio of the Value added (current US$) in 1961 in Guyana to that in India?
Offer a terse response. 0.01. What is the ratio of the Value added (current US$) of 1962 in Guyana to that in India?
Your response must be concise. 0.01. What is the ratio of the Value added (current US$) of 1963 in Guyana to that in India?
Provide a short and direct response. 0.01. What is the ratio of the Value added (current US$) of 1960 in Honduras to that in India?
Keep it short and to the point. 0.01. What is the ratio of the Value added (current US$) of 1961 in Honduras to that in India?
Offer a terse response. 0.01. What is the ratio of the Value added (current US$) in 1962 in Honduras to that in India?
Ensure brevity in your answer.  0.01. What is the ratio of the Value added (current US$) in 1963 in Honduras to that in India?
Your answer should be very brief. 0.01. What is the difference between the highest and the second highest Value added (current US$) in 1960?
Offer a very short reply. 1.18e+1. What is the difference between the highest and the second highest Value added (current US$) of 1961?
Make the answer very short. 1.30e+1. What is the difference between the highest and the second highest Value added (current US$) in 1962?
Your answer should be very brief. 1.42e+1. What is the difference between the highest and the second highest Value added (current US$) of 1963?
Your response must be concise. 1.55e+1. What is the difference between the highest and the lowest Value added (current US$) in 1960?
Give a very brief answer. 1.86e+1. What is the difference between the highest and the lowest Value added (current US$) of 1961?
Offer a very short reply. 2.05e+1. What is the difference between the highest and the lowest Value added (current US$) of 1962?
Your answer should be very brief. 2.24e+1. What is the difference between the highest and the lowest Value added (current US$) in 1963?
Make the answer very short. 2.49e+1. 